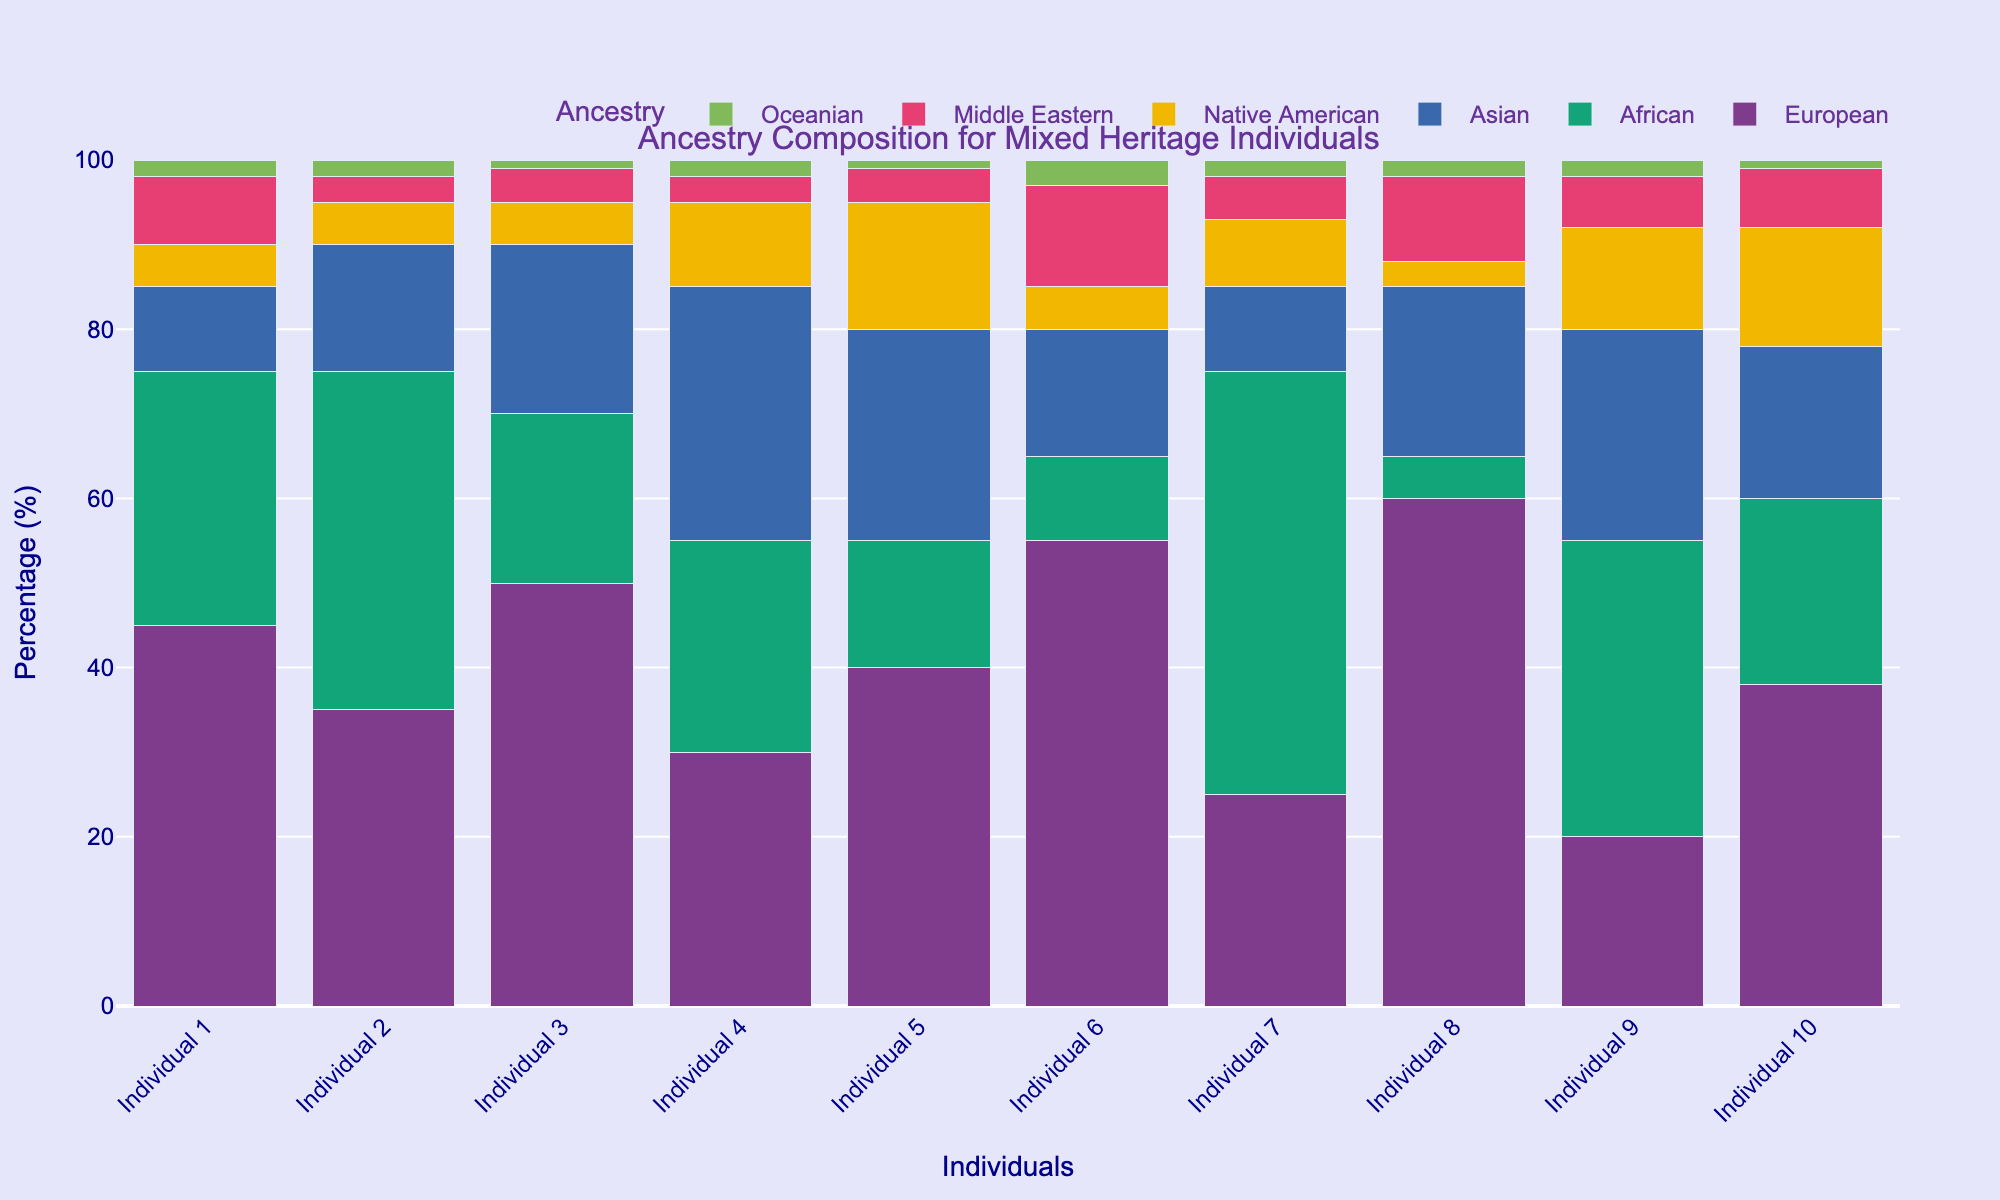What's the most common ancestry among the individuals? Look at the height of the bars for each ancestry across all individuals. The European ancestry bars are generally the tallest for most individuals.
Answer: European Which individual has the highest percentage of African ancestry? Compare the heights of the African ancestry bars across all individuals. Individual 7 has the tallest African ancestry bar at 50%.
Answer: Individual 7 Which individual has the most balanced ancestry composition, considering all ancestries are present? Look for an individual where the bars for all ancestries are more evenly distributed. Individual 4 has a relatively balanced composition with significant contributions from all ancestries.
Answer: Individual 4 What is the total percentage of Middle Eastern ancestry for Individuals 1, 2, and 3 combined? Sum the percentages of Middle Eastern ancestry for Individuals 1, 2, and 3. (8 + 3 + 4) = 15%.
Answer: 15% Which ancestry has the lowest overall representation across all individuals? Look at the heights of the bars for the ancestries across all individuals. Oceanian ancestry has the shortest bars overall.
Answer: Oceanian Compare the percentage of Asian ancestry in Individuals 5 and 8. Who has the higher percentage? Compare the heights of the Asian ancestry bars for Individuals 5 and 8. Individual 8 has a higher percentage at 20% compared to Individual 5's 25%.
Answer: Individual 5 What is the average percentage of Native American ancestry for all individuals? Sum the percentages of Native American ancestry for all individuals and divide by the number of individuals. (5+5+5+10+15+5+8+3+12+14)/10 = 8.2%
Answer: 8.2% Among Individuals 6 and 9, who has a higher combined percentage of European and African ancestry? Add the percentages of European and African ancestry for Individuals 6 and 9. (55 + 10) = 65% for Individual 6 and (20 + 35) = 55% for Individual 9. Individual 6 has a higher combined percentage.
Answer: Individual 6 What is the difference in percentage of European ancestry between Individuals 3 and 8? Subtract the percentage of European ancestry of Individual 8 from Individual 3. 50% - 60% = -10%.
Answer: -10% 